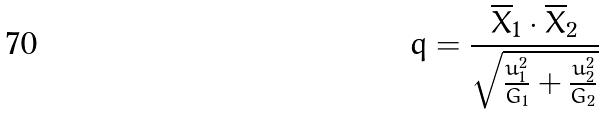Convert formula to latex. <formula><loc_0><loc_0><loc_500><loc_500>q = \frac { \overline { X } _ { 1 } \cdot \overline { X } _ { 2 } } { \sqrt { \frac { u _ { 1 } ^ { 2 } } { G _ { 1 } } + \frac { u _ { 2 } ^ { 2 } } { G _ { 2 } } } }</formula> 